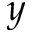<formula> <loc_0><loc_0><loc_500><loc_500>y</formula> 